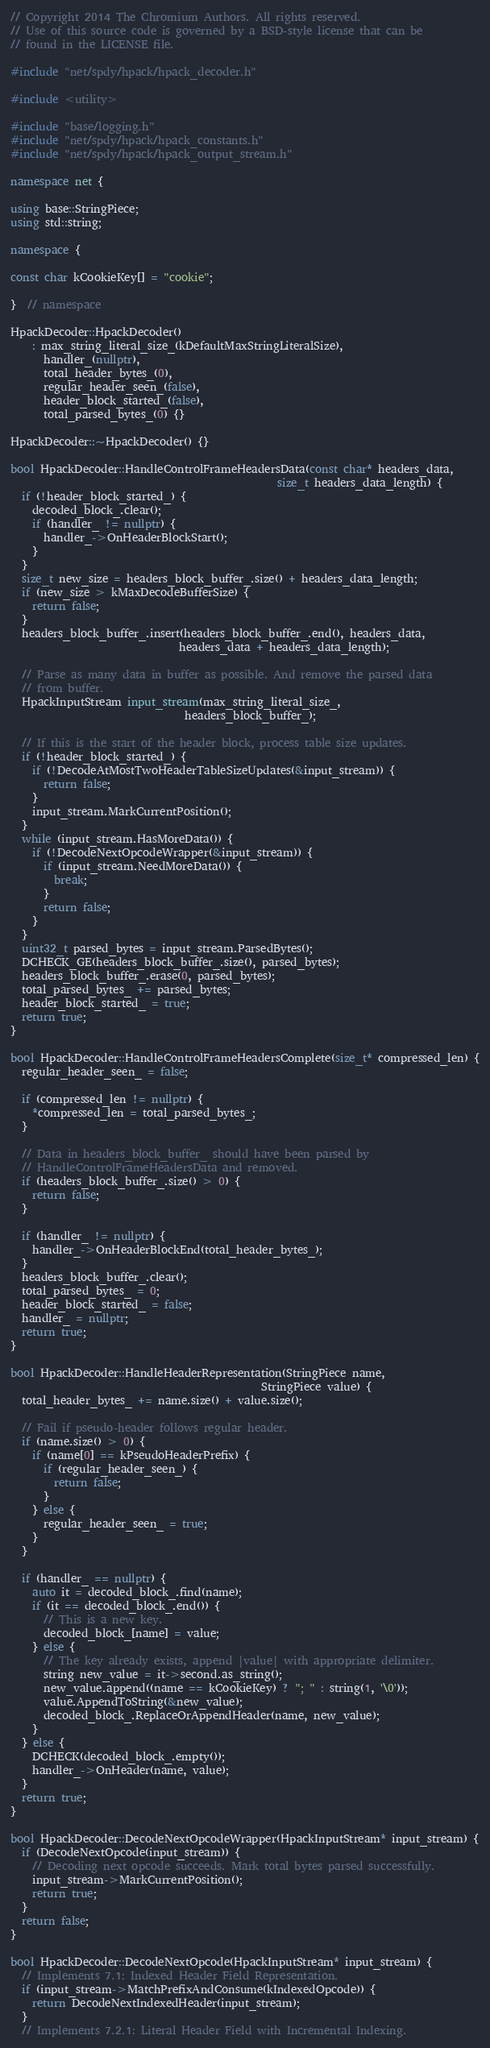Convert code to text. <code><loc_0><loc_0><loc_500><loc_500><_C++_>// Copyright 2014 The Chromium Authors. All rights reserved.
// Use of this source code is governed by a BSD-style license that can be
// found in the LICENSE file.

#include "net/spdy/hpack/hpack_decoder.h"

#include <utility>

#include "base/logging.h"
#include "net/spdy/hpack/hpack_constants.h"
#include "net/spdy/hpack/hpack_output_stream.h"

namespace net {

using base::StringPiece;
using std::string;

namespace {

const char kCookieKey[] = "cookie";

}  // namespace

HpackDecoder::HpackDecoder()
    : max_string_literal_size_(kDefaultMaxStringLiteralSize),
      handler_(nullptr),
      total_header_bytes_(0),
      regular_header_seen_(false),
      header_block_started_(false),
      total_parsed_bytes_(0) {}

HpackDecoder::~HpackDecoder() {}

bool HpackDecoder::HandleControlFrameHeadersData(const char* headers_data,
                                                 size_t headers_data_length) {
  if (!header_block_started_) {
    decoded_block_.clear();
    if (handler_ != nullptr) {
      handler_->OnHeaderBlockStart();
    }
  }
  size_t new_size = headers_block_buffer_.size() + headers_data_length;
  if (new_size > kMaxDecodeBufferSize) {
    return false;
  }
  headers_block_buffer_.insert(headers_block_buffer_.end(), headers_data,
                               headers_data + headers_data_length);

  // Parse as many data in buffer as possible. And remove the parsed data
  // from buffer.
  HpackInputStream input_stream(max_string_literal_size_,
                                headers_block_buffer_);

  // If this is the start of the header block, process table size updates.
  if (!header_block_started_) {
    if (!DecodeAtMostTwoHeaderTableSizeUpdates(&input_stream)) {
      return false;
    }
    input_stream.MarkCurrentPosition();
  }
  while (input_stream.HasMoreData()) {
    if (!DecodeNextOpcodeWrapper(&input_stream)) {
      if (input_stream.NeedMoreData()) {
        break;
      }
      return false;
    }
  }
  uint32_t parsed_bytes = input_stream.ParsedBytes();
  DCHECK_GE(headers_block_buffer_.size(), parsed_bytes);
  headers_block_buffer_.erase(0, parsed_bytes);
  total_parsed_bytes_ += parsed_bytes;
  header_block_started_ = true;
  return true;
}

bool HpackDecoder::HandleControlFrameHeadersComplete(size_t* compressed_len) {
  regular_header_seen_ = false;

  if (compressed_len != nullptr) {
    *compressed_len = total_parsed_bytes_;
  }

  // Data in headers_block_buffer_ should have been parsed by
  // HandleControlFrameHeadersData and removed.
  if (headers_block_buffer_.size() > 0) {
    return false;
  }

  if (handler_ != nullptr) {
    handler_->OnHeaderBlockEnd(total_header_bytes_);
  }
  headers_block_buffer_.clear();
  total_parsed_bytes_ = 0;
  header_block_started_ = false;
  handler_ = nullptr;
  return true;
}

bool HpackDecoder::HandleHeaderRepresentation(StringPiece name,
                                              StringPiece value) {
  total_header_bytes_ += name.size() + value.size();

  // Fail if pseudo-header follows regular header.
  if (name.size() > 0) {
    if (name[0] == kPseudoHeaderPrefix) {
      if (regular_header_seen_) {
        return false;
      }
    } else {
      regular_header_seen_ = true;
    }
  }

  if (handler_ == nullptr) {
    auto it = decoded_block_.find(name);
    if (it == decoded_block_.end()) {
      // This is a new key.
      decoded_block_[name] = value;
    } else {
      // The key already exists, append |value| with appropriate delimiter.
      string new_value = it->second.as_string();
      new_value.append((name == kCookieKey) ? "; " : string(1, '\0'));
      value.AppendToString(&new_value);
      decoded_block_.ReplaceOrAppendHeader(name, new_value);
    }
  } else {
    DCHECK(decoded_block_.empty());
    handler_->OnHeader(name, value);
  }
  return true;
}

bool HpackDecoder::DecodeNextOpcodeWrapper(HpackInputStream* input_stream) {
  if (DecodeNextOpcode(input_stream)) {
    // Decoding next opcode succeeds. Mark total bytes parsed successfully.
    input_stream->MarkCurrentPosition();
    return true;
  }
  return false;
}

bool HpackDecoder::DecodeNextOpcode(HpackInputStream* input_stream) {
  // Implements 7.1: Indexed Header Field Representation.
  if (input_stream->MatchPrefixAndConsume(kIndexedOpcode)) {
    return DecodeNextIndexedHeader(input_stream);
  }
  // Implements 7.2.1: Literal Header Field with Incremental Indexing.</code> 